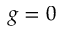<formula> <loc_0><loc_0><loc_500><loc_500>g = 0</formula> 